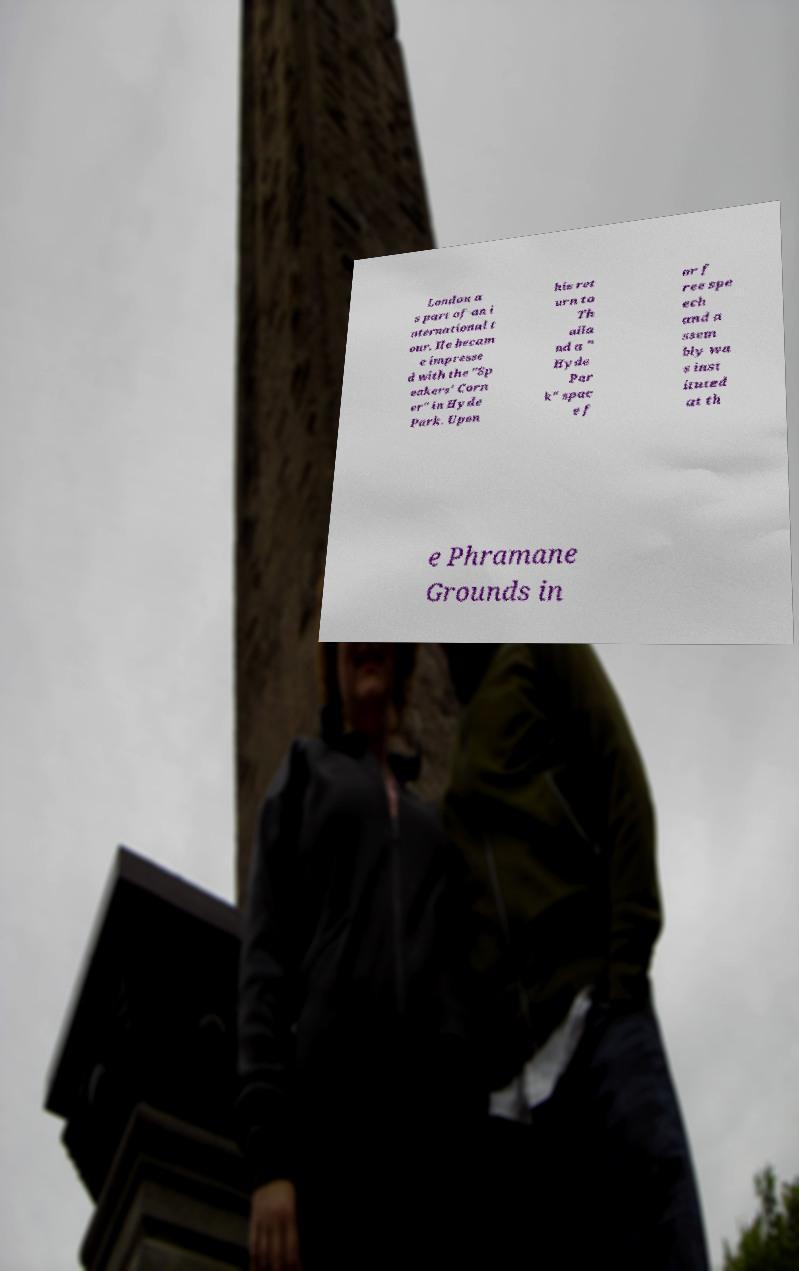What messages or text are displayed in this image? I need them in a readable, typed format. London a s part of an i nternational t our. He becam e impresse d with the "Sp eakers' Corn er" in Hyde Park. Upon his ret urn to Th aila nd a " Hyde Par k" spac e f or f ree spe ech and a ssem bly wa s inst ituted at th e Phramane Grounds in 